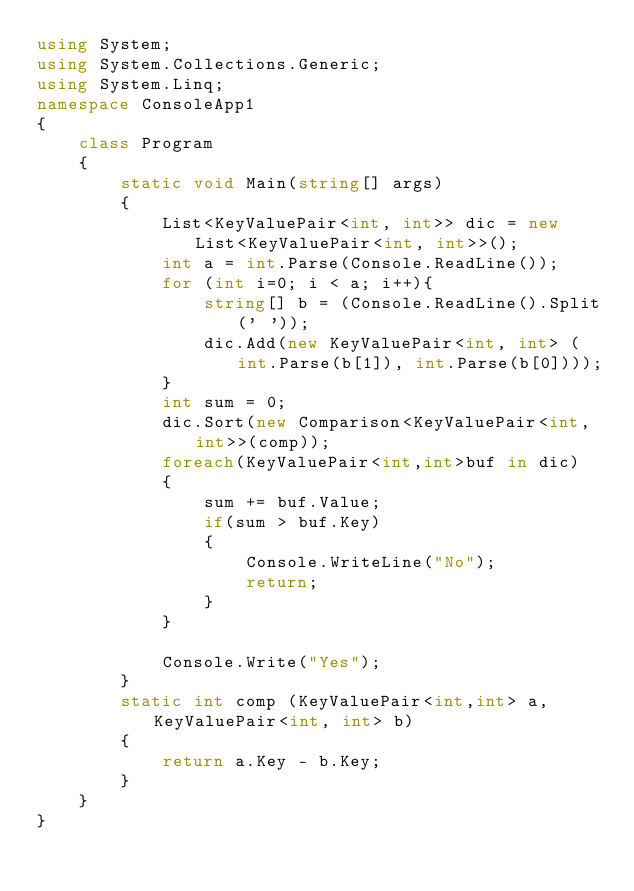<code> <loc_0><loc_0><loc_500><loc_500><_C#_>using System;
using System.Collections.Generic;
using System.Linq;
namespace ConsoleApp1
{
    class Program
    {
        static void Main(string[] args)
        {
            List<KeyValuePair<int, int>> dic = new List<KeyValuePair<int, int>>();
            int a = int.Parse(Console.ReadLine());
            for (int i=0; i < a; i++){
                string[] b = (Console.ReadLine().Split(' '));
                dic.Add(new KeyValuePair<int, int> (int.Parse(b[1]), int.Parse(b[0])));
            }
            int sum = 0;
            dic.Sort(new Comparison<KeyValuePair<int, int>>(comp));
            foreach(KeyValuePair<int,int>buf in dic)
            {
                sum += buf.Value;
                if(sum > buf.Key)
                {
                    Console.WriteLine("No");
                    return;
                }
            }
            
            Console.Write("Yes");
        }
        static int comp (KeyValuePair<int,int> a, KeyValuePair<int, int> b)
        {
            return a.Key - b.Key;
        }
    }
}</code> 